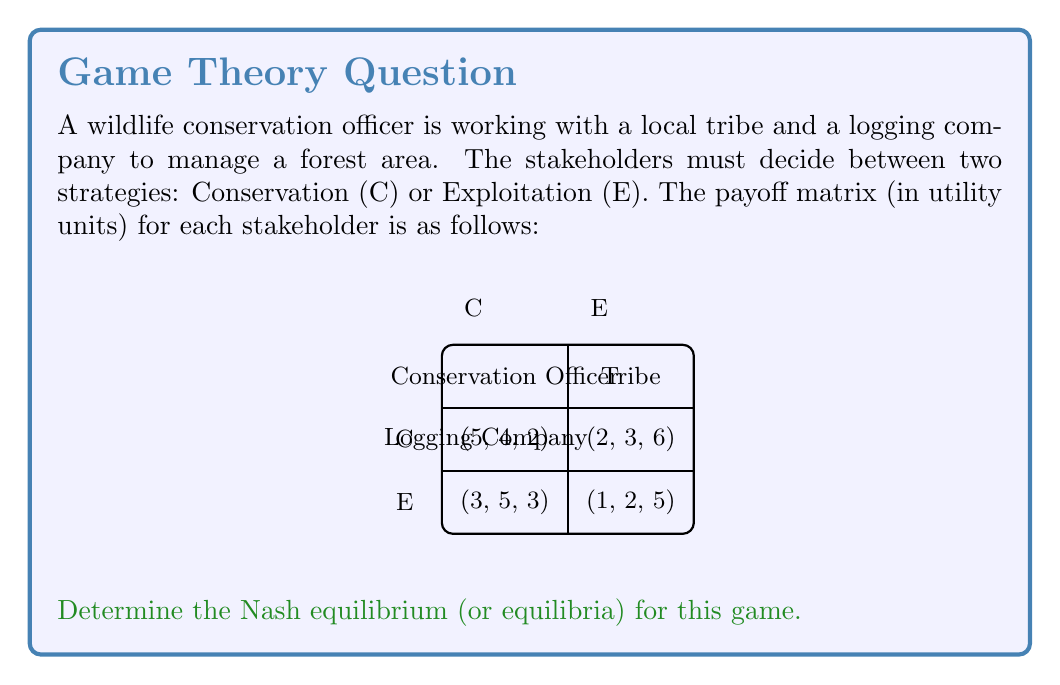Provide a solution to this math problem. To find the Nash equilibrium, we need to analyze each stakeholder's best response to the other players' strategies.

1. For the Conservation Officer:
   - If others choose (C,C): 5 > 3, so choose C
   - If others choose (C,E): 2 > 1, so choose C
   - If others choose (E,C): 5 > 3, so choose C
   - If others choose (E,E): 2 > 1, so choose C
   Best response: Always choose C

2. For the Tribe:
   - If others choose (C,C): 4 > 3, so choose C
   - If others choose (C,E): 5 > 4, so choose E
   - If others choose (E,C): 3 > 2, so choose C
   - If others choose (E,E): 5 > 2, so choose E
   Best response: Match Logging Company's choice

3. For the Logging Company:
   - If others choose (C,C): 6 > 2, so choose E
   - If others choose (C,E): 6 > 2, so choose E
   - If others choose (E,C): 5 > 3, so choose E
   - If others choose (E,E): 5 > 3, so choose E
   Best response: Always choose E

To find the Nash equilibrium, we look for a combination of strategies where no player can unilaterally improve their payoff by changing their strategy.

Given the best responses:
- Conservation Officer always chooses C
- Tribe matches Logging Company's choice
- Logging Company always chooses E

The only stable combination is (C, E, E), where:
- Conservation Officer chooses C
- Tribe chooses E
- Logging Company chooses E

This results in payoffs (2, 3, 6), and no player can unilaterally improve their payoff by changing their strategy.

Therefore, the Nash equilibrium for this game is (C, E, E).
Answer: (C, E, E) 